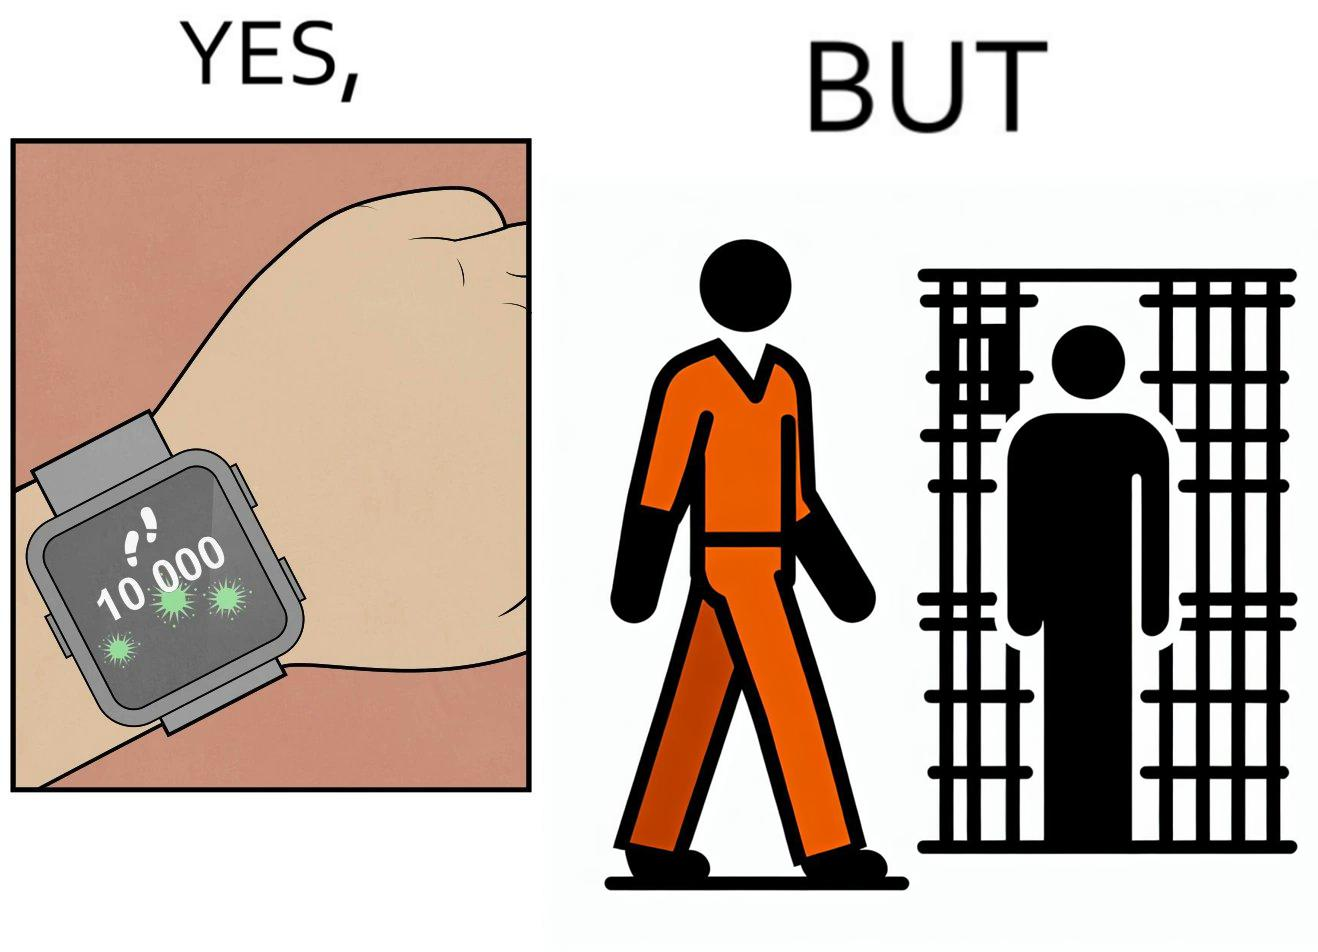Explain the humor or irony in this image. The image is ironical, as the smartwatch on the person's wrist shows 10,000 steps completed as an accomplishment, while showing later that the person is apparently walking inside a jail as a prisoner. 